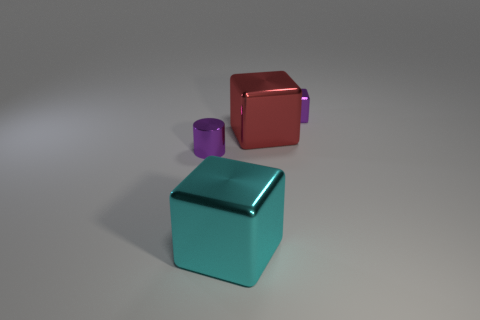How many other big metal objects have the same shape as the large cyan object?
Provide a succinct answer. 1. There is a big shiny thing behind the cyan shiny block; what number of cylinders are behind it?
Provide a succinct answer. 0. What number of shiny objects are either brown things or tiny things?
Offer a terse response. 2. Are there any other small cubes that have the same material as the purple block?
Give a very brief answer. No. What number of objects are either large metallic objects that are right of the big cyan metal cube or small purple metallic objects to the left of the big red shiny cube?
Provide a succinct answer. 2. There is a cylinder that is in front of the tiny purple cube; is its color the same as the small shiny cube?
Provide a short and direct response. Yes. What number of other things are the same color as the cylinder?
Offer a very short reply. 1. Do the purple metal object that is to the left of the cyan shiny object and the red metallic block have the same size?
Offer a terse response. No. The purple metallic thing that is the same shape as the red thing is what size?
Offer a very short reply. Small. Is the number of tiny shiny cubes in front of the cyan shiny object the same as the number of cubes in front of the red metal cube?
Offer a very short reply. No. 